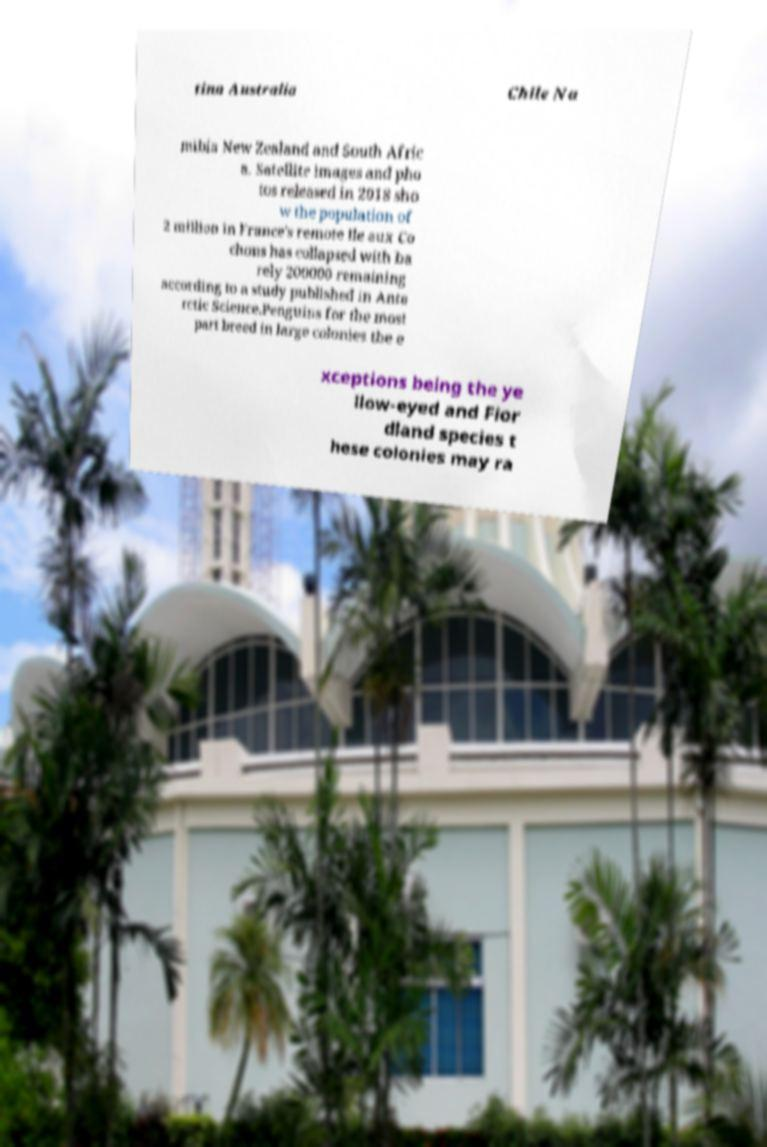There's text embedded in this image that I need extracted. Can you transcribe it verbatim? tina Australia Chile Na mibia New Zealand and South Afric a. Satellite images and pho tos released in 2018 sho w the population of 2 million in France's remote Ile aux Co chons has collapsed with ba rely 200000 remaining according to a study published in Anta rctic Science.Penguins for the most part breed in large colonies the e xceptions being the ye llow-eyed and Fior dland species t hese colonies may ra 